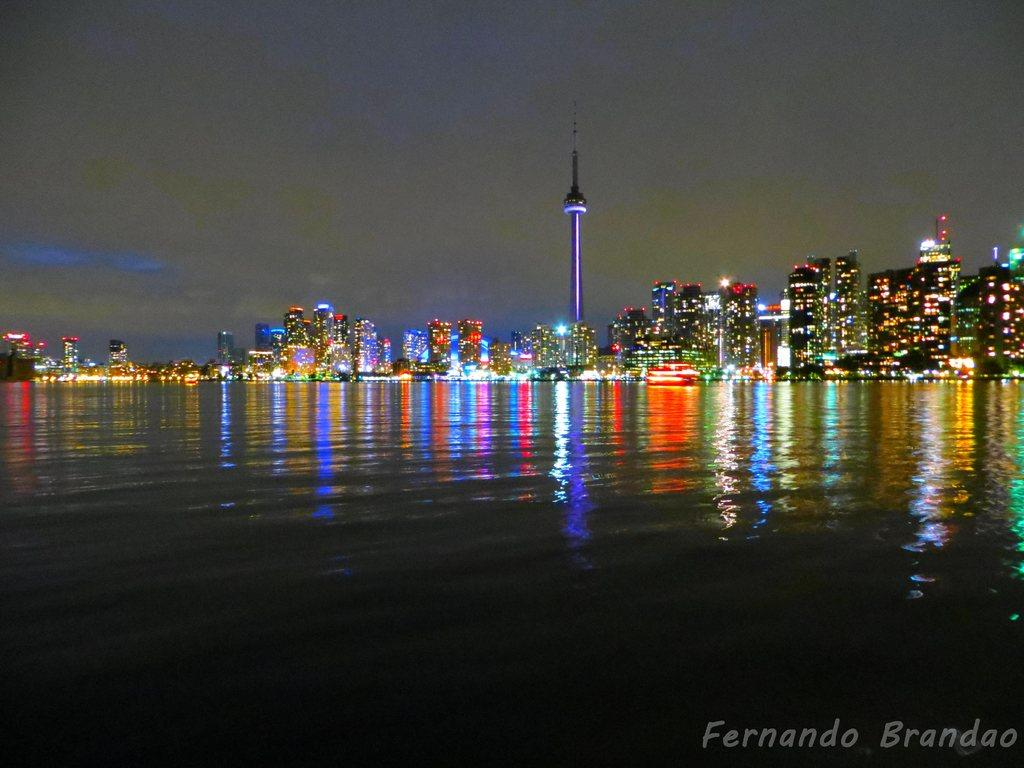What type of structures are illuminated in the image? There are buildings with lights in the image. What natural element is visible in the image? There is water visible in the image. What can be seen in the background of the image? The sky is visible in the background of the image. Is there any additional information or marking in the image? Yes, there is a watermark in the bottom right corner of the image. What type of punishment is being administered to the boot in the image? There is no boot or any indication of punishment present in the image. 